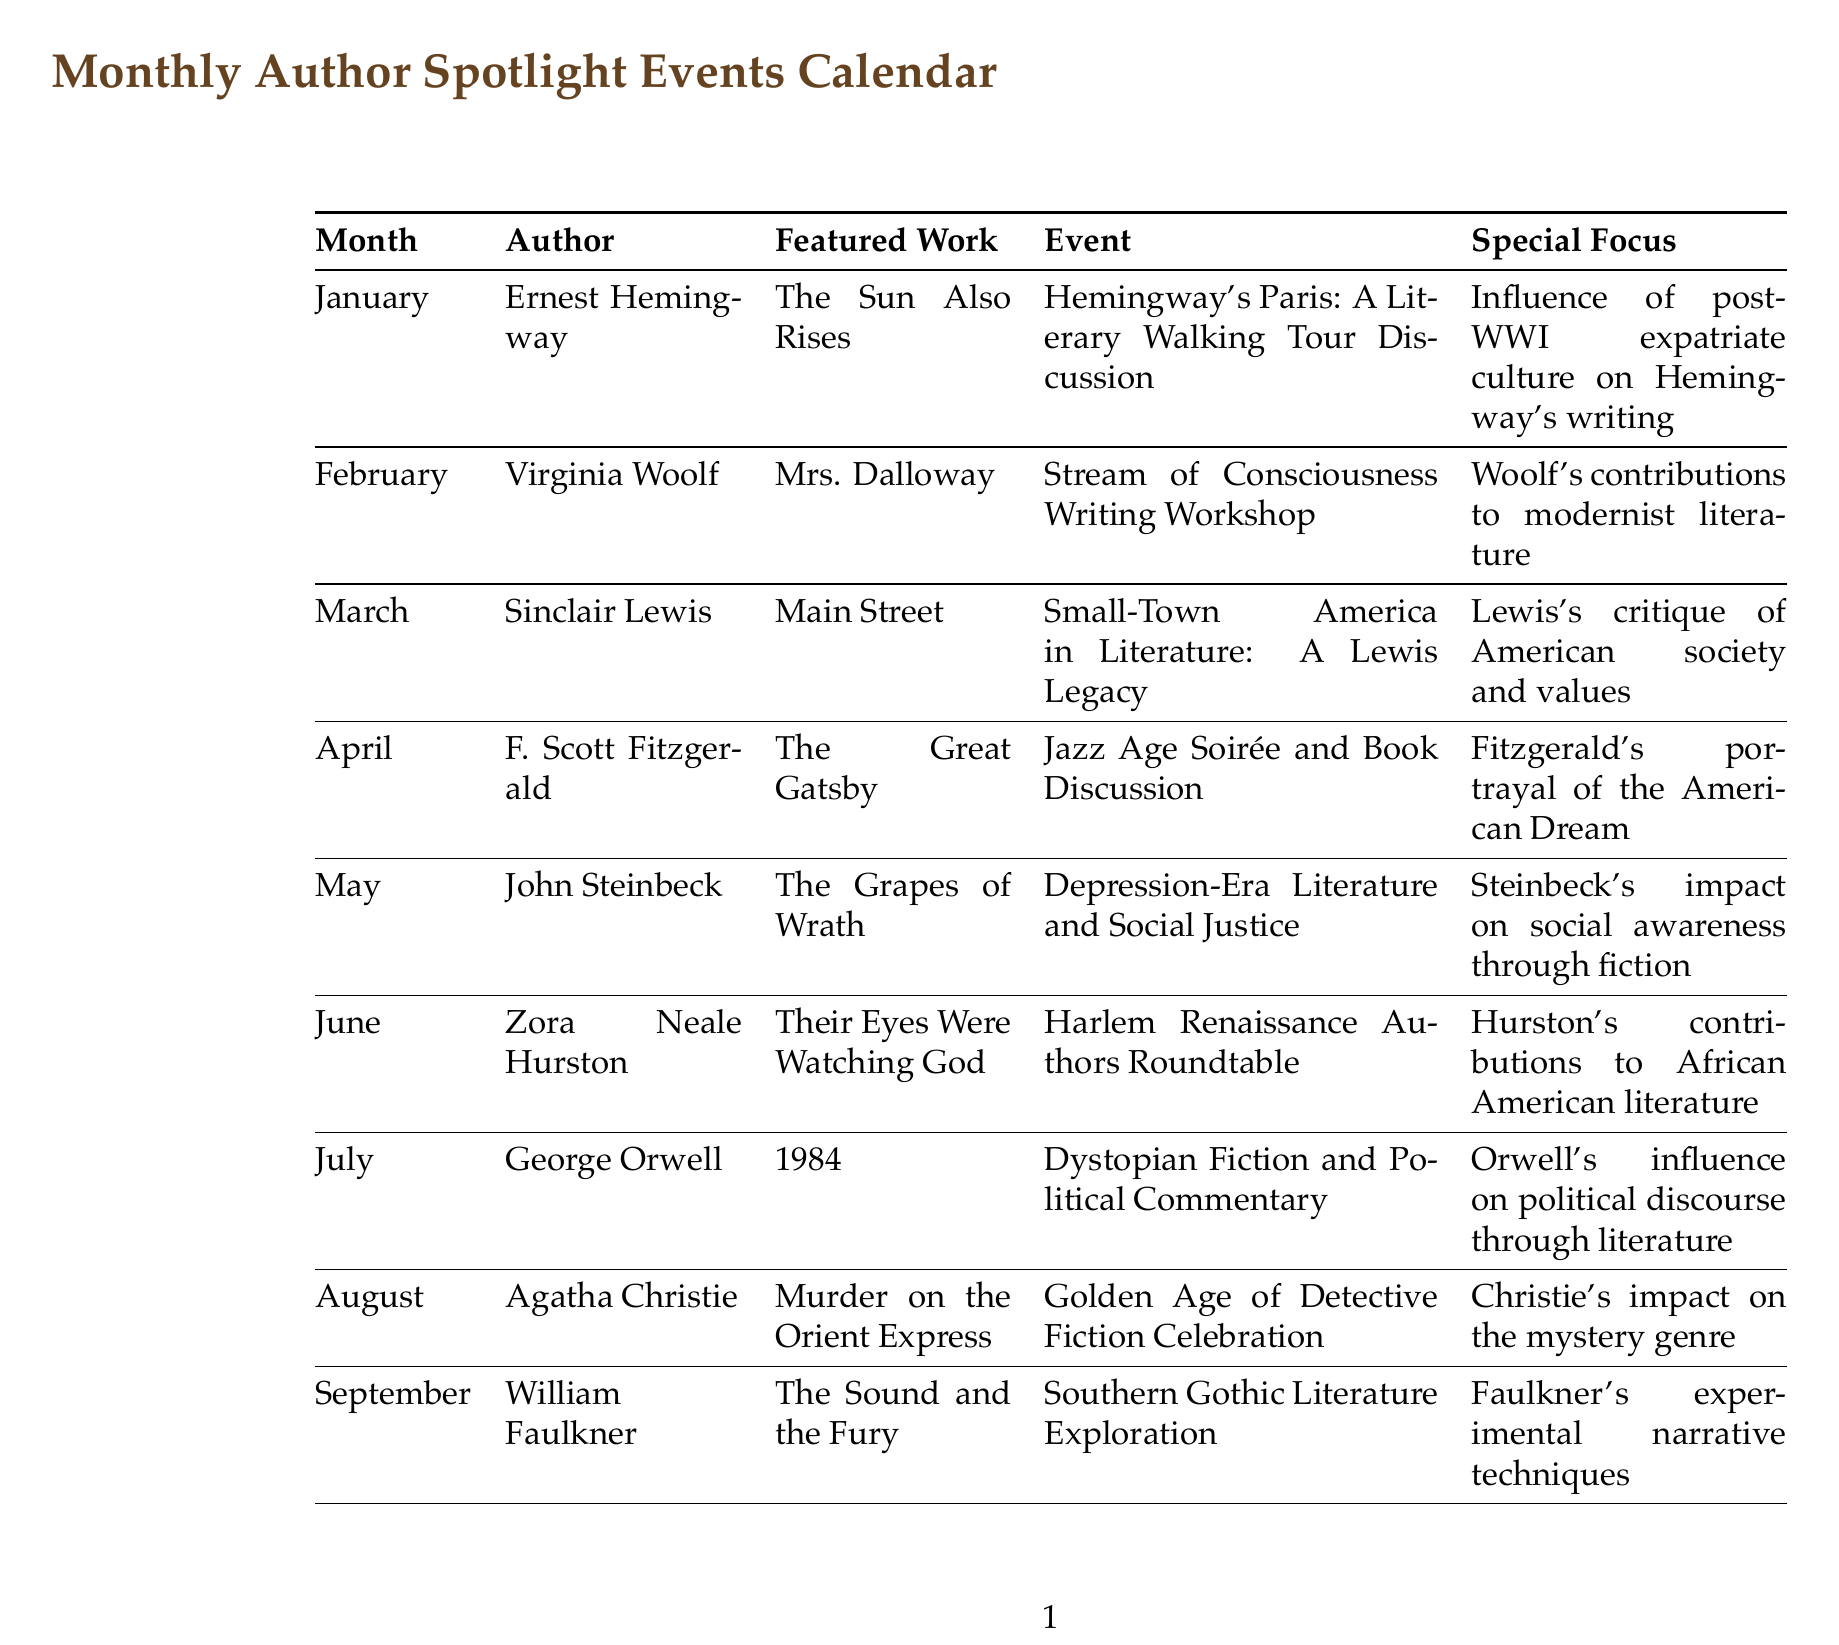What is the featured work for January? The featured work for January is listed as "The Sun Also Rises" by Ernest Hemingway.
Answer: The Sun Also Rises Which author is spotlighted in October? The author spotlighted in October is Sinclair Lewis, as mentioned in the calendar.
Answer: Sinclair Lewis What is the special focus of the event in June? The special focus of the event in June highlights Hurston's contributions to African American literature.
Answer: Hurston's contributions to African American literature How many authors feature in the calendar? The calendar lists 12 different authors across the months, indicating the total number of authors featured.
Answer: 12 Which event occurs in March? The event in March discusses the small-town America in literature and relates to Sinclair Lewis's legacy.
Answer: Small-Town America in Literature: A Lewis Legacy What year does the calendar focus on for the authors? The calendar specifically highlights 20th-century literature, as noted in the title of the document.
Answer: 20th century Which author wrote "The Grapes of Wrath"? The calendar identifies John Steinbeck as the author of "The Grapes of Wrath."
Answer: John Steinbeck What type of literature does the event in July explore? The event in July explores dystopian fiction and its political commentary, as detailed in the document.
Answer: Dystopian fiction What does the event in February discuss? The event in February is a workshop focused on the stream of consciousness writing style, based on Virginia Woolf's work.
Answer: Stream of Consciousness Writing Workshop 